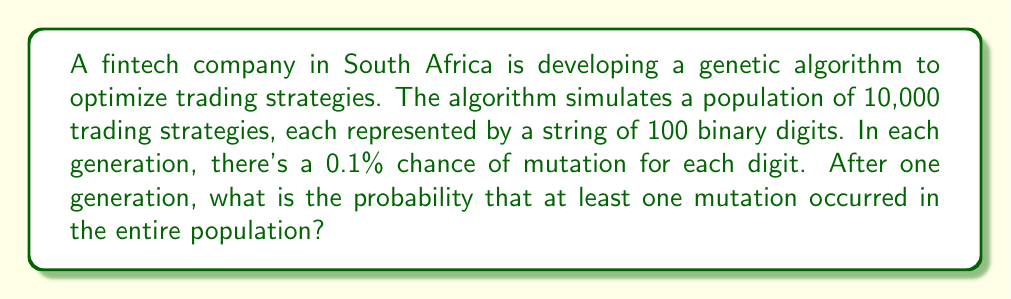Can you solve this math problem? To solve this problem, we'll use probability theory and the concept of complementary events. Let's break it down step-by-step:

1) First, let's calculate the probability of no mutations occurring in a single digit:
   $P(\text{no mutation in one digit}) = 1 - 0.001 = 0.999$

2) For a single strategy (100 digits), the probability of no mutations is:
   $P(\text{no mutations in one strategy}) = (0.999)^{100}$

3) For the entire population (10,000 strategies), the probability of no mutations is:
   $P(\text{no mutations in population}) = ((0.999)^{100})^{10000}$

4) The probability of at least one mutation is the complement of no mutations:
   $P(\text{at least one mutation}) = 1 - P(\text{no mutations in population})$

5) Let's calculate this step by step:
   $P(\text{at least one mutation}) = 1 - ((0.999)^{100})^{10000}$
   $= 1 - (0.904837)^{10000}$
   $= 1 - 1.01 \times 10^{-434}$
   $\approx 0.999999999999999999999999999999999999999999999999...$

6) This probability is extremely close to 1, indicating that it's almost certain that at least one mutation will occur in the population after one generation.
Answer: The probability that at least one mutation occurred in the entire population after one generation is approximately $0.999999999999999999999999999999999999999999999999...$ or $1 - 1.01 \times 10^{-434}$. 